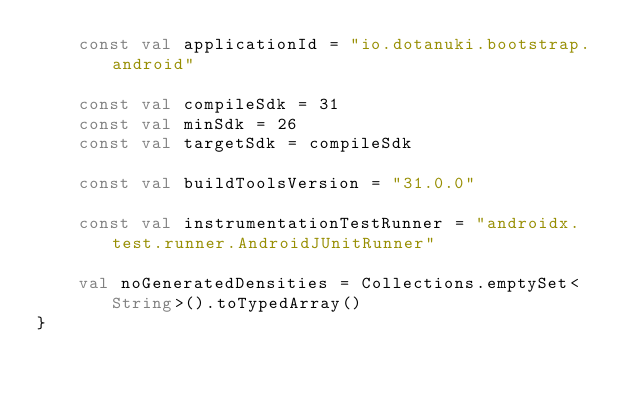Convert code to text. <code><loc_0><loc_0><loc_500><loc_500><_Kotlin_>    const val applicationId = "io.dotanuki.bootstrap.android"

    const val compileSdk = 31
    const val minSdk = 26
    const val targetSdk = compileSdk

    const val buildToolsVersion = "31.0.0"

    const val instrumentationTestRunner = "androidx.test.runner.AndroidJUnitRunner"

    val noGeneratedDensities = Collections.emptySet<String>().toTypedArray()
}
</code> 